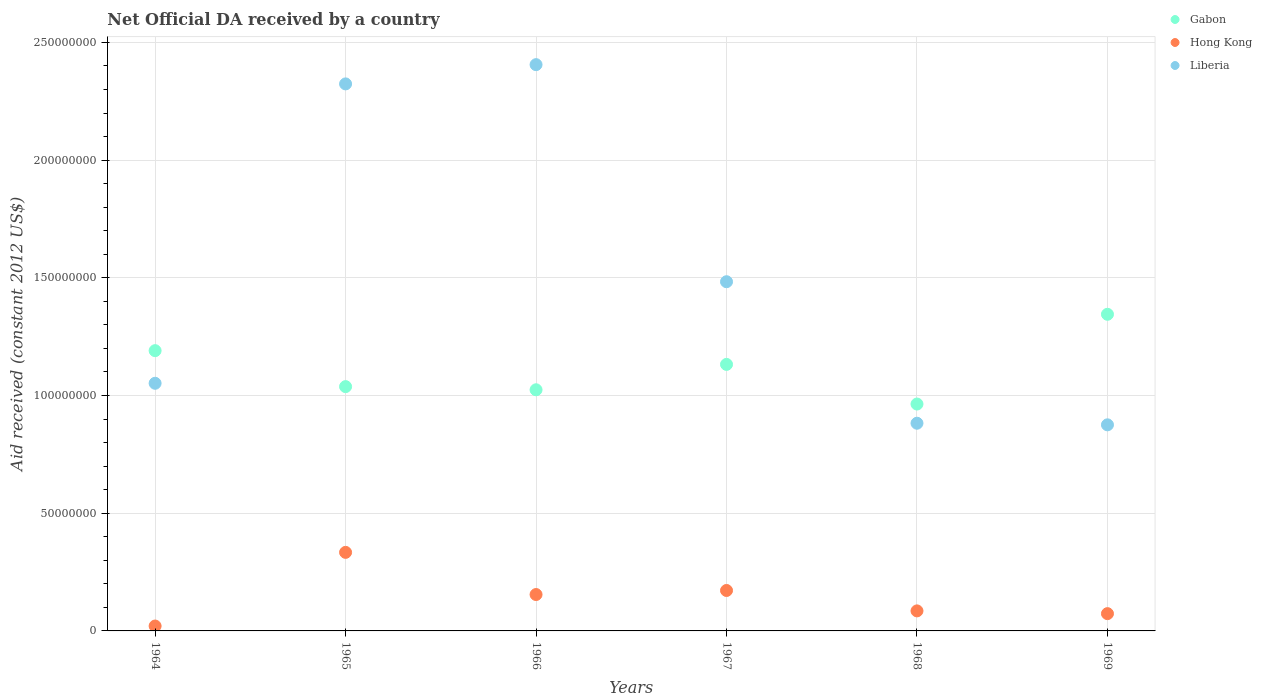What is the net official development assistance aid received in Hong Kong in 1967?
Ensure brevity in your answer.  1.72e+07. Across all years, what is the maximum net official development assistance aid received in Hong Kong?
Make the answer very short. 3.34e+07. Across all years, what is the minimum net official development assistance aid received in Liberia?
Keep it short and to the point. 8.76e+07. In which year was the net official development assistance aid received in Liberia maximum?
Your answer should be very brief. 1966. In which year was the net official development assistance aid received in Liberia minimum?
Offer a terse response. 1969. What is the total net official development assistance aid received in Liberia in the graph?
Offer a terse response. 9.02e+08. What is the difference between the net official development assistance aid received in Liberia in 1964 and that in 1965?
Offer a terse response. -1.27e+08. What is the difference between the net official development assistance aid received in Liberia in 1969 and the net official development assistance aid received in Gabon in 1967?
Provide a short and direct response. -2.57e+07. What is the average net official development assistance aid received in Liberia per year?
Keep it short and to the point. 1.50e+08. In the year 1964, what is the difference between the net official development assistance aid received in Hong Kong and net official development assistance aid received in Gabon?
Your answer should be very brief. -1.17e+08. What is the ratio of the net official development assistance aid received in Hong Kong in 1964 to that in 1968?
Give a very brief answer. 0.24. Is the net official development assistance aid received in Liberia in 1965 less than that in 1967?
Provide a short and direct response. No. What is the difference between the highest and the second highest net official development assistance aid received in Gabon?
Ensure brevity in your answer.  1.54e+07. What is the difference between the highest and the lowest net official development assistance aid received in Liberia?
Your answer should be very brief. 1.53e+08. Is the sum of the net official development assistance aid received in Liberia in 1964 and 1965 greater than the maximum net official development assistance aid received in Gabon across all years?
Offer a terse response. Yes. Is it the case that in every year, the sum of the net official development assistance aid received in Liberia and net official development assistance aid received in Gabon  is greater than the net official development assistance aid received in Hong Kong?
Provide a short and direct response. Yes. Does the net official development assistance aid received in Hong Kong monotonically increase over the years?
Your answer should be very brief. No. Is the net official development assistance aid received in Gabon strictly less than the net official development assistance aid received in Liberia over the years?
Make the answer very short. No. How many years are there in the graph?
Keep it short and to the point. 6. What is the difference between two consecutive major ticks on the Y-axis?
Your answer should be very brief. 5.00e+07. Does the graph contain any zero values?
Give a very brief answer. No. How many legend labels are there?
Provide a succinct answer. 3. How are the legend labels stacked?
Provide a succinct answer. Vertical. What is the title of the graph?
Ensure brevity in your answer.  Net Official DA received by a country. What is the label or title of the X-axis?
Make the answer very short. Years. What is the label or title of the Y-axis?
Offer a very short reply. Aid received (constant 2012 US$). What is the Aid received (constant 2012 US$) of Gabon in 1964?
Give a very brief answer. 1.19e+08. What is the Aid received (constant 2012 US$) of Hong Kong in 1964?
Keep it short and to the point. 2.08e+06. What is the Aid received (constant 2012 US$) of Liberia in 1964?
Make the answer very short. 1.05e+08. What is the Aid received (constant 2012 US$) of Gabon in 1965?
Give a very brief answer. 1.04e+08. What is the Aid received (constant 2012 US$) of Hong Kong in 1965?
Offer a terse response. 3.34e+07. What is the Aid received (constant 2012 US$) of Liberia in 1965?
Your answer should be compact. 2.32e+08. What is the Aid received (constant 2012 US$) of Gabon in 1966?
Your answer should be very brief. 1.02e+08. What is the Aid received (constant 2012 US$) in Hong Kong in 1966?
Offer a very short reply. 1.55e+07. What is the Aid received (constant 2012 US$) of Liberia in 1966?
Offer a very short reply. 2.41e+08. What is the Aid received (constant 2012 US$) of Gabon in 1967?
Your response must be concise. 1.13e+08. What is the Aid received (constant 2012 US$) in Hong Kong in 1967?
Ensure brevity in your answer.  1.72e+07. What is the Aid received (constant 2012 US$) in Liberia in 1967?
Give a very brief answer. 1.48e+08. What is the Aid received (constant 2012 US$) of Gabon in 1968?
Your response must be concise. 9.64e+07. What is the Aid received (constant 2012 US$) in Hong Kong in 1968?
Offer a very short reply. 8.51e+06. What is the Aid received (constant 2012 US$) of Liberia in 1968?
Make the answer very short. 8.82e+07. What is the Aid received (constant 2012 US$) in Gabon in 1969?
Your answer should be very brief. 1.35e+08. What is the Aid received (constant 2012 US$) in Hong Kong in 1969?
Your answer should be compact. 7.34e+06. What is the Aid received (constant 2012 US$) in Liberia in 1969?
Ensure brevity in your answer.  8.76e+07. Across all years, what is the maximum Aid received (constant 2012 US$) of Gabon?
Your answer should be very brief. 1.35e+08. Across all years, what is the maximum Aid received (constant 2012 US$) in Hong Kong?
Your answer should be very brief. 3.34e+07. Across all years, what is the maximum Aid received (constant 2012 US$) in Liberia?
Your answer should be compact. 2.41e+08. Across all years, what is the minimum Aid received (constant 2012 US$) in Gabon?
Your answer should be very brief. 9.64e+07. Across all years, what is the minimum Aid received (constant 2012 US$) in Hong Kong?
Ensure brevity in your answer.  2.08e+06. Across all years, what is the minimum Aid received (constant 2012 US$) of Liberia?
Give a very brief answer. 8.76e+07. What is the total Aid received (constant 2012 US$) in Gabon in the graph?
Provide a succinct answer. 6.69e+08. What is the total Aid received (constant 2012 US$) of Hong Kong in the graph?
Offer a very short reply. 8.39e+07. What is the total Aid received (constant 2012 US$) of Liberia in the graph?
Provide a succinct answer. 9.02e+08. What is the difference between the Aid received (constant 2012 US$) of Gabon in 1964 and that in 1965?
Offer a terse response. 1.53e+07. What is the difference between the Aid received (constant 2012 US$) of Hong Kong in 1964 and that in 1965?
Ensure brevity in your answer.  -3.13e+07. What is the difference between the Aid received (constant 2012 US$) of Liberia in 1964 and that in 1965?
Offer a very short reply. -1.27e+08. What is the difference between the Aid received (constant 2012 US$) of Gabon in 1964 and that in 1966?
Provide a succinct answer. 1.66e+07. What is the difference between the Aid received (constant 2012 US$) of Hong Kong in 1964 and that in 1966?
Make the answer very short. -1.34e+07. What is the difference between the Aid received (constant 2012 US$) of Liberia in 1964 and that in 1966?
Offer a very short reply. -1.35e+08. What is the difference between the Aid received (constant 2012 US$) in Gabon in 1964 and that in 1967?
Give a very brief answer. 5.84e+06. What is the difference between the Aid received (constant 2012 US$) of Hong Kong in 1964 and that in 1967?
Your response must be concise. -1.51e+07. What is the difference between the Aid received (constant 2012 US$) in Liberia in 1964 and that in 1967?
Offer a terse response. -4.31e+07. What is the difference between the Aid received (constant 2012 US$) in Gabon in 1964 and that in 1968?
Offer a terse response. 2.27e+07. What is the difference between the Aid received (constant 2012 US$) of Hong Kong in 1964 and that in 1968?
Ensure brevity in your answer.  -6.43e+06. What is the difference between the Aid received (constant 2012 US$) of Liberia in 1964 and that in 1968?
Your answer should be compact. 1.70e+07. What is the difference between the Aid received (constant 2012 US$) in Gabon in 1964 and that in 1969?
Offer a terse response. -1.54e+07. What is the difference between the Aid received (constant 2012 US$) of Hong Kong in 1964 and that in 1969?
Offer a very short reply. -5.26e+06. What is the difference between the Aid received (constant 2012 US$) of Liberia in 1964 and that in 1969?
Keep it short and to the point. 1.76e+07. What is the difference between the Aid received (constant 2012 US$) of Gabon in 1965 and that in 1966?
Make the answer very short. 1.34e+06. What is the difference between the Aid received (constant 2012 US$) of Hong Kong in 1965 and that in 1966?
Offer a very short reply. 1.79e+07. What is the difference between the Aid received (constant 2012 US$) of Liberia in 1965 and that in 1966?
Your response must be concise. -8.18e+06. What is the difference between the Aid received (constant 2012 US$) in Gabon in 1965 and that in 1967?
Offer a very short reply. -9.44e+06. What is the difference between the Aid received (constant 2012 US$) of Hong Kong in 1965 and that in 1967?
Offer a very short reply. 1.62e+07. What is the difference between the Aid received (constant 2012 US$) of Liberia in 1965 and that in 1967?
Keep it short and to the point. 8.40e+07. What is the difference between the Aid received (constant 2012 US$) in Gabon in 1965 and that in 1968?
Keep it short and to the point. 7.40e+06. What is the difference between the Aid received (constant 2012 US$) in Hong Kong in 1965 and that in 1968?
Your response must be concise. 2.49e+07. What is the difference between the Aid received (constant 2012 US$) in Liberia in 1965 and that in 1968?
Keep it short and to the point. 1.44e+08. What is the difference between the Aid received (constant 2012 US$) of Gabon in 1965 and that in 1969?
Your response must be concise. -3.07e+07. What is the difference between the Aid received (constant 2012 US$) of Hong Kong in 1965 and that in 1969?
Your response must be concise. 2.60e+07. What is the difference between the Aid received (constant 2012 US$) of Liberia in 1965 and that in 1969?
Provide a short and direct response. 1.45e+08. What is the difference between the Aid received (constant 2012 US$) in Gabon in 1966 and that in 1967?
Make the answer very short. -1.08e+07. What is the difference between the Aid received (constant 2012 US$) in Hong Kong in 1966 and that in 1967?
Your answer should be very brief. -1.72e+06. What is the difference between the Aid received (constant 2012 US$) of Liberia in 1966 and that in 1967?
Offer a terse response. 9.22e+07. What is the difference between the Aid received (constant 2012 US$) in Gabon in 1966 and that in 1968?
Give a very brief answer. 6.06e+06. What is the difference between the Aid received (constant 2012 US$) of Hong Kong in 1966 and that in 1968?
Offer a terse response. 6.95e+06. What is the difference between the Aid received (constant 2012 US$) of Liberia in 1966 and that in 1968?
Your answer should be very brief. 1.52e+08. What is the difference between the Aid received (constant 2012 US$) of Gabon in 1966 and that in 1969?
Keep it short and to the point. -3.21e+07. What is the difference between the Aid received (constant 2012 US$) in Hong Kong in 1966 and that in 1969?
Provide a succinct answer. 8.12e+06. What is the difference between the Aid received (constant 2012 US$) of Liberia in 1966 and that in 1969?
Keep it short and to the point. 1.53e+08. What is the difference between the Aid received (constant 2012 US$) in Gabon in 1967 and that in 1968?
Ensure brevity in your answer.  1.68e+07. What is the difference between the Aid received (constant 2012 US$) of Hong Kong in 1967 and that in 1968?
Your answer should be very brief. 8.67e+06. What is the difference between the Aid received (constant 2012 US$) in Liberia in 1967 and that in 1968?
Provide a short and direct response. 6.01e+07. What is the difference between the Aid received (constant 2012 US$) in Gabon in 1967 and that in 1969?
Make the answer very short. -2.13e+07. What is the difference between the Aid received (constant 2012 US$) of Hong Kong in 1967 and that in 1969?
Offer a terse response. 9.84e+06. What is the difference between the Aid received (constant 2012 US$) of Liberia in 1967 and that in 1969?
Keep it short and to the point. 6.08e+07. What is the difference between the Aid received (constant 2012 US$) of Gabon in 1968 and that in 1969?
Keep it short and to the point. -3.81e+07. What is the difference between the Aid received (constant 2012 US$) of Hong Kong in 1968 and that in 1969?
Your answer should be very brief. 1.17e+06. What is the difference between the Aid received (constant 2012 US$) in Liberia in 1968 and that in 1969?
Keep it short and to the point. 6.80e+05. What is the difference between the Aid received (constant 2012 US$) in Gabon in 1964 and the Aid received (constant 2012 US$) in Hong Kong in 1965?
Give a very brief answer. 8.57e+07. What is the difference between the Aid received (constant 2012 US$) of Gabon in 1964 and the Aid received (constant 2012 US$) of Liberia in 1965?
Your answer should be compact. -1.13e+08. What is the difference between the Aid received (constant 2012 US$) of Hong Kong in 1964 and the Aid received (constant 2012 US$) of Liberia in 1965?
Your answer should be compact. -2.30e+08. What is the difference between the Aid received (constant 2012 US$) of Gabon in 1964 and the Aid received (constant 2012 US$) of Hong Kong in 1966?
Keep it short and to the point. 1.04e+08. What is the difference between the Aid received (constant 2012 US$) in Gabon in 1964 and the Aid received (constant 2012 US$) in Liberia in 1966?
Offer a terse response. -1.22e+08. What is the difference between the Aid received (constant 2012 US$) of Hong Kong in 1964 and the Aid received (constant 2012 US$) of Liberia in 1966?
Offer a very short reply. -2.38e+08. What is the difference between the Aid received (constant 2012 US$) in Gabon in 1964 and the Aid received (constant 2012 US$) in Hong Kong in 1967?
Ensure brevity in your answer.  1.02e+08. What is the difference between the Aid received (constant 2012 US$) in Gabon in 1964 and the Aid received (constant 2012 US$) in Liberia in 1967?
Ensure brevity in your answer.  -2.93e+07. What is the difference between the Aid received (constant 2012 US$) in Hong Kong in 1964 and the Aid received (constant 2012 US$) in Liberia in 1967?
Provide a short and direct response. -1.46e+08. What is the difference between the Aid received (constant 2012 US$) in Gabon in 1964 and the Aid received (constant 2012 US$) in Hong Kong in 1968?
Your response must be concise. 1.11e+08. What is the difference between the Aid received (constant 2012 US$) of Gabon in 1964 and the Aid received (constant 2012 US$) of Liberia in 1968?
Provide a short and direct response. 3.08e+07. What is the difference between the Aid received (constant 2012 US$) of Hong Kong in 1964 and the Aid received (constant 2012 US$) of Liberia in 1968?
Give a very brief answer. -8.62e+07. What is the difference between the Aid received (constant 2012 US$) of Gabon in 1964 and the Aid received (constant 2012 US$) of Hong Kong in 1969?
Offer a terse response. 1.12e+08. What is the difference between the Aid received (constant 2012 US$) in Gabon in 1964 and the Aid received (constant 2012 US$) in Liberia in 1969?
Ensure brevity in your answer.  3.15e+07. What is the difference between the Aid received (constant 2012 US$) of Hong Kong in 1964 and the Aid received (constant 2012 US$) of Liberia in 1969?
Provide a short and direct response. -8.55e+07. What is the difference between the Aid received (constant 2012 US$) in Gabon in 1965 and the Aid received (constant 2012 US$) in Hong Kong in 1966?
Make the answer very short. 8.83e+07. What is the difference between the Aid received (constant 2012 US$) of Gabon in 1965 and the Aid received (constant 2012 US$) of Liberia in 1966?
Provide a succinct answer. -1.37e+08. What is the difference between the Aid received (constant 2012 US$) of Hong Kong in 1965 and the Aid received (constant 2012 US$) of Liberia in 1966?
Provide a succinct answer. -2.07e+08. What is the difference between the Aid received (constant 2012 US$) of Gabon in 1965 and the Aid received (constant 2012 US$) of Hong Kong in 1967?
Your answer should be compact. 8.66e+07. What is the difference between the Aid received (constant 2012 US$) in Gabon in 1965 and the Aid received (constant 2012 US$) in Liberia in 1967?
Ensure brevity in your answer.  -4.46e+07. What is the difference between the Aid received (constant 2012 US$) in Hong Kong in 1965 and the Aid received (constant 2012 US$) in Liberia in 1967?
Keep it short and to the point. -1.15e+08. What is the difference between the Aid received (constant 2012 US$) of Gabon in 1965 and the Aid received (constant 2012 US$) of Hong Kong in 1968?
Ensure brevity in your answer.  9.53e+07. What is the difference between the Aid received (constant 2012 US$) of Gabon in 1965 and the Aid received (constant 2012 US$) of Liberia in 1968?
Offer a terse response. 1.56e+07. What is the difference between the Aid received (constant 2012 US$) in Hong Kong in 1965 and the Aid received (constant 2012 US$) in Liberia in 1968?
Ensure brevity in your answer.  -5.49e+07. What is the difference between the Aid received (constant 2012 US$) in Gabon in 1965 and the Aid received (constant 2012 US$) in Hong Kong in 1969?
Make the answer very short. 9.64e+07. What is the difference between the Aid received (constant 2012 US$) in Gabon in 1965 and the Aid received (constant 2012 US$) in Liberia in 1969?
Your answer should be compact. 1.62e+07. What is the difference between the Aid received (constant 2012 US$) in Hong Kong in 1965 and the Aid received (constant 2012 US$) in Liberia in 1969?
Ensure brevity in your answer.  -5.42e+07. What is the difference between the Aid received (constant 2012 US$) of Gabon in 1966 and the Aid received (constant 2012 US$) of Hong Kong in 1967?
Provide a succinct answer. 8.53e+07. What is the difference between the Aid received (constant 2012 US$) of Gabon in 1966 and the Aid received (constant 2012 US$) of Liberia in 1967?
Offer a terse response. -4.59e+07. What is the difference between the Aid received (constant 2012 US$) of Hong Kong in 1966 and the Aid received (constant 2012 US$) of Liberia in 1967?
Give a very brief answer. -1.33e+08. What is the difference between the Aid received (constant 2012 US$) in Gabon in 1966 and the Aid received (constant 2012 US$) in Hong Kong in 1968?
Keep it short and to the point. 9.39e+07. What is the difference between the Aid received (constant 2012 US$) of Gabon in 1966 and the Aid received (constant 2012 US$) of Liberia in 1968?
Your answer should be compact. 1.42e+07. What is the difference between the Aid received (constant 2012 US$) of Hong Kong in 1966 and the Aid received (constant 2012 US$) of Liberia in 1968?
Make the answer very short. -7.28e+07. What is the difference between the Aid received (constant 2012 US$) of Gabon in 1966 and the Aid received (constant 2012 US$) of Hong Kong in 1969?
Offer a terse response. 9.51e+07. What is the difference between the Aid received (constant 2012 US$) in Gabon in 1966 and the Aid received (constant 2012 US$) in Liberia in 1969?
Give a very brief answer. 1.49e+07. What is the difference between the Aid received (constant 2012 US$) in Hong Kong in 1966 and the Aid received (constant 2012 US$) in Liberia in 1969?
Give a very brief answer. -7.21e+07. What is the difference between the Aid received (constant 2012 US$) in Gabon in 1967 and the Aid received (constant 2012 US$) in Hong Kong in 1968?
Keep it short and to the point. 1.05e+08. What is the difference between the Aid received (constant 2012 US$) in Gabon in 1967 and the Aid received (constant 2012 US$) in Liberia in 1968?
Offer a terse response. 2.50e+07. What is the difference between the Aid received (constant 2012 US$) of Hong Kong in 1967 and the Aid received (constant 2012 US$) of Liberia in 1968?
Offer a very short reply. -7.10e+07. What is the difference between the Aid received (constant 2012 US$) of Gabon in 1967 and the Aid received (constant 2012 US$) of Hong Kong in 1969?
Provide a succinct answer. 1.06e+08. What is the difference between the Aid received (constant 2012 US$) in Gabon in 1967 and the Aid received (constant 2012 US$) in Liberia in 1969?
Provide a short and direct response. 2.57e+07. What is the difference between the Aid received (constant 2012 US$) of Hong Kong in 1967 and the Aid received (constant 2012 US$) of Liberia in 1969?
Provide a succinct answer. -7.04e+07. What is the difference between the Aid received (constant 2012 US$) of Gabon in 1968 and the Aid received (constant 2012 US$) of Hong Kong in 1969?
Offer a terse response. 8.90e+07. What is the difference between the Aid received (constant 2012 US$) of Gabon in 1968 and the Aid received (constant 2012 US$) of Liberia in 1969?
Your answer should be very brief. 8.83e+06. What is the difference between the Aid received (constant 2012 US$) of Hong Kong in 1968 and the Aid received (constant 2012 US$) of Liberia in 1969?
Your answer should be very brief. -7.90e+07. What is the average Aid received (constant 2012 US$) of Gabon per year?
Give a very brief answer. 1.12e+08. What is the average Aid received (constant 2012 US$) in Hong Kong per year?
Provide a succinct answer. 1.40e+07. What is the average Aid received (constant 2012 US$) of Liberia per year?
Your response must be concise. 1.50e+08. In the year 1964, what is the difference between the Aid received (constant 2012 US$) of Gabon and Aid received (constant 2012 US$) of Hong Kong?
Keep it short and to the point. 1.17e+08. In the year 1964, what is the difference between the Aid received (constant 2012 US$) in Gabon and Aid received (constant 2012 US$) in Liberia?
Offer a terse response. 1.39e+07. In the year 1964, what is the difference between the Aid received (constant 2012 US$) of Hong Kong and Aid received (constant 2012 US$) of Liberia?
Provide a succinct answer. -1.03e+08. In the year 1965, what is the difference between the Aid received (constant 2012 US$) in Gabon and Aid received (constant 2012 US$) in Hong Kong?
Provide a short and direct response. 7.04e+07. In the year 1965, what is the difference between the Aid received (constant 2012 US$) in Gabon and Aid received (constant 2012 US$) in Liberia?
Offer a terse response. -1.29e+08. In the year 1965, what is the difference between the Aid received (constant 2012 US$) in Hong Kong and Aid received (constant 2012 US$) in Liberia?
Your answer should be compact. -1.99e+08. In the year 1966, what is the difference between the Aid received (constant 2012 US$) of Gabon and Aid received (constant 2012 US$) of Hong Kong?
Offer a very short reply. 8.70e+07. In the year 1966, what is the difference between the Aid received (constant 2012 US$) in Gabon and Aid received (constant 2012 US$) in Liberia?
Give a very brief answer. -1.38e+08. In the year 1966, what is the difference between the Aid received (constant 2012 US$) of Hong Kong and Aid received (constant 2012 US$) of Liberia?
Your response must be concise. -2.25e+08. In the year 1967, what is the difference between the Aid received (constant 2012 US$) of Gabon and Aid received (constant 2012 US$) of Hong Kong?
Make the answer very short. 9.60e+07. In the year 1967, what is the difference between the Aid received (constant 2012 US$) in Gabon and Aid received (constant 2012 US$) in Liberia?
Your answer should be very brief. -3.51e+07. In the year 1967, what is the difference between the Aid received (constant 2012 US$) of Hong Kong and Aid received (constant 2012 US$) of Liberia?
Your answer should be compact. -1.31e+08. In the year 1968, what is the difference between the Aid received (constant 2012 US$) in Gabon and Aid received (constant 2012 US$) in Hong Kong?
Ensure brevity in your answer.  8.79e+07. In the year 1968, what is the difference between the Aid received (constant 2012 US$) of Gabon and Aid received (constant 2012 US$) of Liberia?
Offer a very short reply. 8.15e+06. In the year 1968, what is the difference between the Aid received (constant 2012 US$) of Hong Kong and Aid received (constant 2012 US$) of Liberia?
Ensure brevity in your answer.  -7.97e+07. In the year 1969, what is the difference between the Aid received (constant 2012 US$) of Gabon and Aid received (constant 2012 US$) of Hong Kong?
Make the answer very short. 1.27e+08. In the year 1969, what is the difference between the Aid received (constant 2012 US$) in Gabon and Aid received (constant 2012 US$) in Liberia?
Your answer should be compact. 4.70e+07. In the year 1969, what is the difference between the Aid received (constant 2012 US$) of Hong Kong and Aid received (constant 2012 US$) of Liberia?
Your response must be concise. -8.02e+07. What is the ratio of the Aid received (constant 2012 US$) of Gabon in 1964 to that in 1965?
Provide a short and direct response. 1.15. What is the ratio of the Aid received (constant 2012 US$) of Hong Kong in 1964 to that in 1965?
Offer a terse response. 0.06. What is the ratio of the Aid received (constant 2012 US$) of Liberia in 1964 to that in 1965?
Your answer should be very brief. 0.45. What is the ratio of the Aid received (constant 2012 US$) in Gabon in 1964 to that in 1966?
Provide a short and direct response. 1.16. What is the ratio of the Aid received (constant 2012 US$) of Hong Kong in 1964 to that in 1966?
Keep it short and to the point. 0.13. What is the ratio of the Aid received (constant 2012 US$) of Liberia in 1964 to that in 1966?
Your answer should be compact. 0.44. What is the ratio of the Aid received (constant 2012 US$) in Gabon in 1964 to that in 1967?
Provide a short and direct response. 1.05. What is the ratio of the Aid received (constant 2012 US$) in Hong Kong in 1964 to that in 1967?
Make the answer very short. 0.12. What is the ratio of the Aid received (constant 2012 US$) of Liberia in 1964 to that in 1967?
Ensure brevity in your answer.  0.71. What is the ratio of the Aid received (constant 2012 US$) of Gabon in 1964 to that in 1968?
Offer a terse response. 1.24. What is the ratio of the Aid received (constant 2012 US$) in Hong Kong in 1964 to that in 1968?
Offer a terse response. 0.24. What is the ratio of the Aid received (constant 2012 US$) in Liberia in 1964 to that in 1968?
Ensure brevity in your answer.  1.19. What is the ratio of the Aid received (constant 2012 US$) of Gabon in 1964 to that in 1969?
Your answer should be very brief. 0.89. What is the ratio of the Aid received (constant 2012 US$) of Hong Kong in 1964 to that in 1969?
Your answer should be compact. 0.28. What is the ratio of the Aid received (constant 2012 US$) in Liberia in 1964 to that in 1969?
Make the answer very short. 1.2. What is the ratio of the Aid received (constant 2012 US$) in Gabon in 1965 to that in 1966?
Give a very brief answer. 1.01. What is the ratio of the Aid received (constant 2012 US$) in Hong Kong in 1965 to that in 1966?
Provide a succinct answer. 2.16. What is the ratio of the Aid received (constant 2012 US$) in Gabon in 1965 to that in 1967?
Provide a short and direct response. 0.92. What is the ratio of the Aid received (constant 2012 US$) in Hong Kong in 1965 to that in 1967?
Give a very brief answer. 1.94. What is the ratio of the Aid received (constant 2012 US$) in Liberia in 1965 to that in 1967?
Offer a very short reply. 1.57. What is the ratio of the Aid received (constant 2012 US$) in Gabon in 1965 to that in 1968?
Provide a succinct answer. 1.08. What is the ratio of the Aid received (constant 2012 US$) of Hong Kong in 1965 to that in 1968?
Keep it short and to the point. 3.92. What is the ratio of the Aid received (constant 2012 US$) in Liberia in 1965 to that in 1968?
Give a very brief answer. 2.63. What is the ratio of the Aid received (constant 2012 US$) in Gabon in 1965 to that in 1969?
Offer a very short reply. 0.77. What is the ratio of the Aid received (constant 2012 US$) in Hong Kong in 1965 to that in 1969?
Offer a very short reply. 4.55. What is the ratio of the Aid received (constant 2012 US$) of Liberia in 1965 to that in 1969?
Your answer should be very brief. 2.65. What is the ratio of the Aid received (constant 2012 US$) of Gabon in 1966 to that in 1967?
Your response must be concise. 0.9. What is the ratio of the Aid received (constant 2012 US$) in Hong Kong in 1966 to that in 1967?
Your response must be concise. 0.9. What is the ratio of the Aid received (constant 2012 US$) in Liberia in 1966 to that in 1967?
Make the answer very short. 1.62. What is the ratio of the Aid received (constant 2012 US$) of Gabon in 1966 to that in 1968?
Offer a very short reply. 1.06. What is the ratio of the Aid received (constant 2012 US$) of Hong Kong in 1966 to that in 1968?
Make the answer very short. 1.82. What is the ratio of the Aid received (constant 2012 US$) in Liberia in 1966 to that in 1968?
Give a very brief answer. 2.73. What is the ratio of the Aid received (constant 2012 US$) of Gabon in 1966 to that in 1969?
Offer a very short reply. 0.76. What is the ratio of the Aid received (constant 2012 US$) in Hong Kong in 1966 to that in 1969?
Your response must be concise. 2.11. What is the ratio of the Aid received (constant 2012 US$) of Liberia in 1966 to that in 1969?
Keep it short and to the point. 2.75. What is the ratio of the Aid received (constant 2012 US$) in Gabon in 1967 to that in 1968?
Your answer should be compact. 1.17. What is the ratio of the Aid received (constant 2012 US$) in Hong Kong in 1967 to that in 1968?
Your response must be concise. 2.02. What is the ratio of the Aid received (constant 2012 US$) in Liberia in 1967 to that in 1968?
Provide a short and direct response. 1.68. What is the ratio of the Aid received (constant 2012 US$) in Gabon in 1967 to that in 1969?
Your answer should be very brief. 0.84. What is the ratio of the Aid received (constant 2012 US$) in Hong Kong in 1967 to that in 1969?
Offer a very short reply. 2.34. What is the ratio of the Aid received (constant 2012 US$) in Liberia in 1967 to that in 1969?
Your response must be concise. 1.69. What is the ratio of the Aid received (constant 2012 US$) of Gabon in 1968 to that in 1969?
Keep it short and to the point. 0.72. What is the ratio of the Aid received (constant 2012 US$) of Hong Kong in 1968 to that in 1969?
Ensure brevity in your answer.  1.16. What is the ratio of the Aid received (constant 2012 US$) of Liberia in 1968 to that in 1969?
Offer a very short reply. 1.01. What is the difference between the highest and the second highest Aid received (constant 2012 US$) of Gabon?
Keep it short and to the point. 1.54e+07. What is the difference between the highest and the second highest Aid received (constant 2012 US$) in Hong Kong?
Ensure brevity in your answer.  1.62e+07. What is the difference between the highest and the second highest Aid received (constant 2012 US$) in Liberia?
Offer a very short reply. 8.18e+06. What is the difference between the highest and the lowest Aid received (constant 2012 US$) in Gabon?
Your answer should be compact. 3.81e+07. What is the difference between the highest and the lowest Aid received (constant 2012 US$) of Hong Kong?
Your answer should be compact. 3.13e+07. What is the difference between the highest and the lowest Aid received (constant 2012 US$) of Liberia?
Keep it short and to the point. 1.53e+08. 